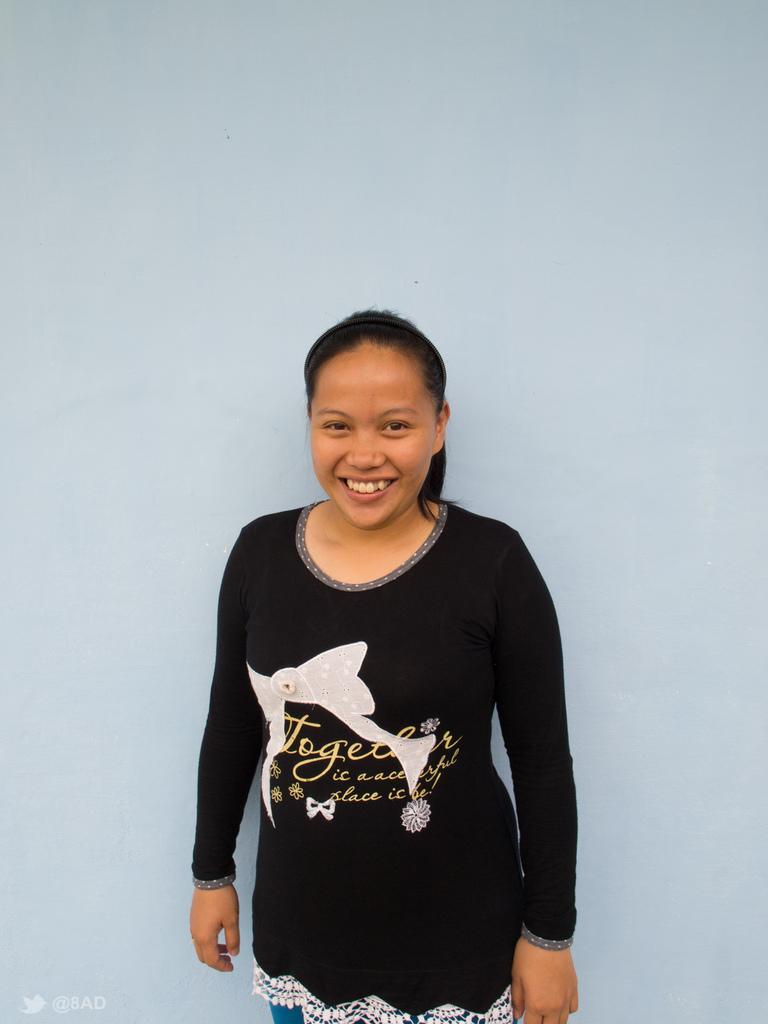In one or two sentences, can you explain what this image depicts? In this image there is a woman with a smile on her face. 